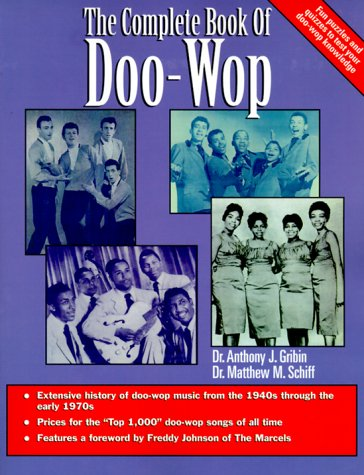Is this a crafts or hobbies related book? No, this book is not related to crafts or hobbies. It is a scholarly treatment of the Doo-Wop music genre, detailing its influences, key songs, and significant musicians. 